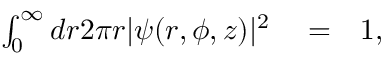<formula> <loc_0><loc_0><loc_500><loc_500>\begin{array} { r l r } { \int _ { 0 } ^ { \infty } d r 2 \pi r | \psi ( r , \phi , z ) | ^ { 2 } } & = } & { 1 , } \end{array}</formula> 